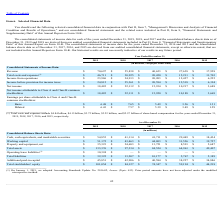From Facebook's financial document, What is the revenue for 2019 and 2018 respectively? The document shows two values: $70,697 and $55,838 (in millions). From the document: "Revenue $ 70,697 $ 55,838 $ 40,653 $ 27,638 $ 17,928 Revenue $ 70,697 $ 55,838 $ 40,653 $ 27,638 $ 17,928..." Also, What is the Income from operations for 2019 and 2018 respectively? The document shows two values: $23,986 and $24,913 (in millions). From the document: "Income from operations $ 23,986 $ 24,913 $ 20,203 $ 12,427 $ 6,225 Income from operations $ 23,986 $ 24,913 $ 20,203 $ 12,427 $ 6,225..." Also, What is the Net income for 2019 and 2018 respectively? The document shows two values: $18,485 and $22,112 (in millions). From the document: "Net income $ 18,485 $ 22,112 $ 15,934 $ 10,217 $ 3,688 Net income $ 18,485 $ 22,112 $ 15,934 $ 10,217 $ 3,688..." Also, can you calculate: What is the change in revenue between 2018 and 2019? Based on the calculation: 70,697-55,838, the result is 14859 (in millions). This is based on the information: "Revenue $ 70,697 $ 55,838 $ 40,653 $ 27,638 $ 17,928 Revenue $ 70,697 $ 55,838 $ 40,653 $ 27,638 $ 17,928..." The key data points involved are: 55,838, 70,697. Also, can you calculate: What is the average revenue for 2018 and 2019? To answer this question, I need to perform calculations using the financial data. The calculation is: (70,697+ 55,838)/2, which equals 63267.5 (in millions). This is based on the information: "Revenue $ 70,697 $ 55,838 $ 40,653 $ 27,638 $ 17,928 Revenue $ 70,697 $ 55,838 $ 40,653 $ 27,638 $ 17,928..." The key data points involved are: 55,838, 70,697. Additionally, Which year has the highest amount of revenue? According to the financial document, 2019. The relevant text states: "2019 2018 2017 2016 2015..." 